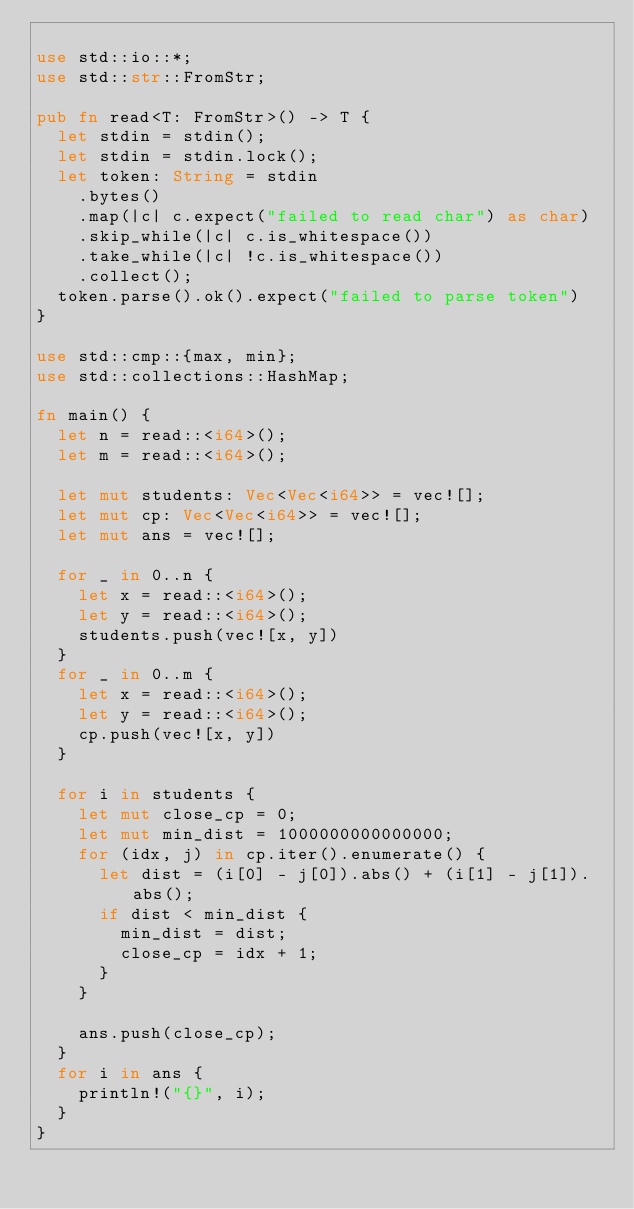<code> <loc_0><loc_0><loc_500><loc_500><_Rust_>
use std::io::*;
use std::str::FromStr;

pub fn read<T: FromStr>() -> T {
  let stdin = stdin();
  let stdin = stdin.lock();
  let token: String = stdin
    .bytes()
    .map(|c| c.expect("failed to read char") as char)
    .skip_while(|c| c.is_whitespace())
    .take_while(|c| !c.is_whitespace())
    .collect();
  token.parse().ok().expect("failed to parse token")
}

use std::cmp::{max, min};
use std::collections::HashMap;

fn main() {
  let n = read::<i64>();
  let m = read::<i64>();

  let mut students: Vec<Vec<i64>> = vec![];
  let mut cp: Vec<Vec<i64>> = vec![];
  let mut ans = vec![];

  for _ in 0..n {
    let x = read::<i64>();
    let y = read::<i64>();
    students.push(vec![x, y])
  }
  for _ in 0..m {
    let x = read::<i64>();
    let y = read::<i64>();
    cp.push(vec![x, y])
  }

  for i in students {
    let mut close_cp = 0;
    let mut min_dist = 1000000000000000;
    for (idx, j) in cp.iter().enumerate() {
      let dist = (i[0] - j[0]).abs() + (i[1] - j[1]).abs();
      if dist < min_dist {
        min_dist = dist;
        close_cp = idx + 1;
      }
    }

    ans.push(close_cp);
  }
  for i in ans {
    println!("{}", i);
  }
}

</code> 